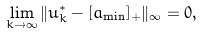Convert formula to latex. <formula><loc_0><loc_0><loc_500><loc_500>\lim _ { k \to \infty } \| u ^ { * } _ { k } - [ a _ { \min } ] _ { + } \| _ { \infty } = 0 ,</formula> 